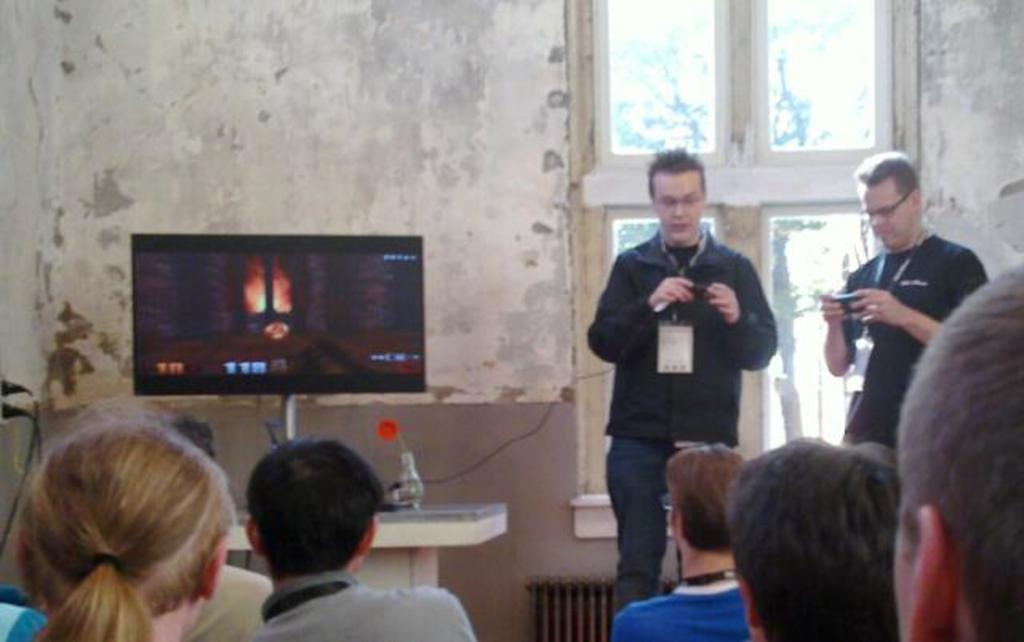Who or what can be seen in the image? There are people in the image. What electronic device is present in the image? There is a television in the image. What can be seen in the background of the image? There is a wall and a window in the background of the image. What type of party is being held in the image? There is no indication of a party in the image; it simply shows people, a television, a wall, and a window. 